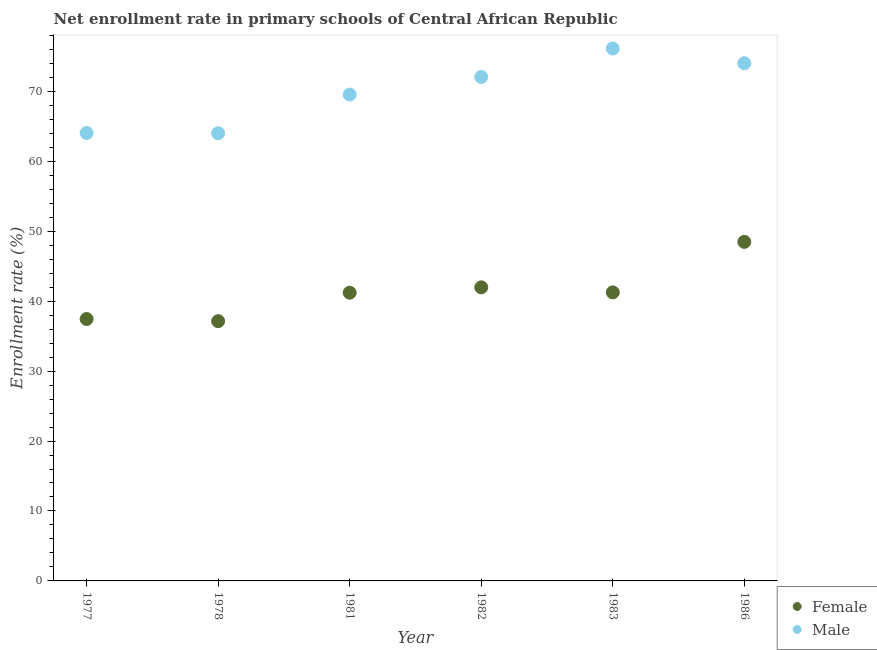What is the enrollment rate of male students in 1982?
Offer a very short reply. 72.04. Across all years, what is the maximum enrollment rate of male students?
Provide a short and direct response. 76.11. Across all years, what is the minimum enrollment rate of male students?
Keep it short and to the point. 64. In which year was the enrollment rate of female students maximum?
Provide a short and direct response. 1986. In which year was the enrollment rate of male students minimum?
Give a very brief answer. 1978. What is the total enrollment rate of female students in the graph?
Your answer should be compact. 247.47. What is the difference between the enrollment rate of male students in 1978 and that in 1981?
Provide a short and direct response. -5.53. What is the difference between the enrollment rate of female students in 1982 and the enrollment rate of male students in 1986?
Provide a short and direct response. -32.05. What is the average enrollment rate of male students per year?
Your response must be concise. 69.95. In the year 1978, what is the difference between the enrollment rate of female students and enrollment rate of male students?
Offer a terse response. -26.86. What is the ratio of the enrollment rate of female students in 1977 to that in 1986?
Make the answer very short. 0.77. Is the difference between the enrollment rate of male students in 1983 and 1986 greater than the difference between the enrollment rate of female students in 1983 and 1986?
Offer a very short reply. Yes. What is the difference between the highest and the second highest enrollment rate of female students?
Offer a terse response. 6.5. What is the difference between the highest and the lowest enrollment rate of male students?
Give a very brief answer. 12.12. In how many years, is the enrollment rate of female students greater than the average enrollment rate of female students taken over all years?
Offer a terse response. 3. Does the enrollment rate of male students monotonically increase over the years?
Ensure brevity in your answer.  No. Is the enrollment rate of male students strictly greater than the enrollment rate of female students over the years?
Keep it short and to the point. Yes. How many years are there in the graph?
Offer a terse response. 6. Where does the legend appear in the graph?
Your answer should be very brief. Bottom right. How are the legend labels stacked?
Your answer should be very brief. Vertical. What is the title of the graph?
Your answer should be compact. Net enrollment rate in primary schools of Central African Republic. What is the label or title of the Y-axis?
Give a very brief answer. Enrollment rate (%). What is the Enrollment rate (%) of Female in 1977?
Keep it short and to the point. 37.44. What is the Enrollment rate (%) of Male in 1977?
Ensure brevity in your answer.  64.03. What is the Enrollment rate (%) of Female in 1978?
Offer a very short reply. 37.13. What is the Enrollment rate (%) in Male in 1978?
Ensure brevity in your answer.  64. What is the Enrollment rate (%) of Female in 1981?
Give a very brief answer. 41.2. What is the Enrollment rate (%) of Male in 1981?
Make the answer very short. 69.53. What is the Enrollment rate (%) in Female in 1982?
Provide a succinct answer. 41.97. What is the Enrollment rate (%) of Male in 1982?
Offer a terse response. 72.04. What is the Enrollment rate (%) in Female in 1983?
Give a very brief answer. 41.25. What is the Enrollment rate (%) in Male in 1983?
Keep it short and to the point. 76.11. What is the Enrollment rate (%) of Female in 1986?
Provide a succinct answer. 48.47. What is the Enrollment rate (%) of Male in 1986?
Your answer should be very brief. 74.01. Across all years, what is the maximum Enrollment rate (%) of Female?
Your answer should be compact. 48.47. Across all years, what is the maximum Enrollment rate (%) in Male?
Offer a terse response. 76.11. Across all years, what is the minimum Enrollment rate (%) of Female?
Your response must be concise. 37.13. Across all years, what is the minimum Enrollment rate (%) of Male?
Offer a very short reply. 64. What is the total Enrollment rate (%) in Female in the graph?
Give a very brief answer. 247.47. What is the total Enrollment rate (%) of Male in the graph?
Your answer should be compact. 419.73. What is the difference between the Enrollment rate (%) in Female in 1977 and that in 1978?
Provide a short and direct response. 0.31. What is the difference between the Enrollment rate (%) in Male in 1977 and that in 1978?
Offer a very short reply. 0.04. What is the difference between the Enrollment rate (%) in Female in 1977 and that in 1981?
Ensure brevity in your answer.  -3.76. What is the difference between the Enrollment rate (%) in Male in 1977 and that in 1981?
Keep it short and to the point. -5.49. What is the difference between the Enrollment rate (%) of Female in 1977 and that in 1982?
Your response must be concise. -4.52. What is the difference between the Enrollment rate (%) in Male in 1977 and that in 1982?
Your answer should be very brief. -8.01. What is the difference between the Enrollment rate (%) of Female in 1977 and that in 1983?
Provide a succinct answer. -3.81. What is the difference between the Enrollment rate (%) of Male in 1977 and that in 1983?
Provide a succinct answer. -12.08. What is the difference between the Enrollment rate (%) in Female in 1977 and that in 1986?
Ensure brevity in your answer.  -11.03. What is the difference between the Enrollment rate (%) of Male in 1977 and that in 1986?
Your answer should be very brief. -9.98. What is the difference between the Enrollment rate (%) in Female in 1978 and that in 1981?
Provide a succinct answer. -4.07. What is the difference between the Enrollment rate (%) of Male in 1978 and that in 1981?
Give a very brief answer. -5.53. What is the difference between the Enrollment rate (%) of Female in 1978 and that in 1982?
Your response must be concise. -4.83. What is the difference between the Enrollment rate (%) in Male in 1978 and that in 1982?
Keep it short and to the point. -8.05. What is the difference between the Enrollment rate (%) in Female in 1978 and that in 1983?
Make the answer very short. -4.12. What is the difference between the Enrollment rate (%) of Male in 1978 and that in 1983?
Make the answer very short. -12.12. What is the difference between the Enrollment rate (%) of Female in 1978 and that in 1986?
Your answer should be very brief. -11.34. What is the difference between the Enrollment rate (%) of Male in 1978 and that in 1986?
Keep it short and to the point. -10.02. What is the difference between the Enrollment rate (%) of Female in 1981 and that in 1982?
Offer a terse response. -0.77. What is the difference between the Enrollment rate (%) of Male in 1981 and that in 1982?
Provide a succinct answer. -2.51. What is the difference between the Enrollment rate (%) in Female in 1981 and that in 1983?
Ensure brevity in your answer.  -0.05. What is the difference between the Enrollment rate (%) of Male in 1981 and that in 1983?
Your answer should be very brief. -6.58. What is the difference between the Enrollment rate (%) of Female in 1981 and that in 1986?
Offer a very short reply. -7.27. What is the difference between the Enrollment rate (%) of Male in 1981 and that in 1986?
Your answer should be compact. -4.49. What is the difference between the Enrollment rate (%) in Female in 1982 and that in 1983?
Your response must be concise. 0.72. What is the difference between the Enrollment rate (%) in Male in 1982 and that in 1983?
Your response must be concise. -4.07. What is the difference between the Enrollment rate (%) of Female in 1982 and that in 1986?
Provide a succinct answer. -6.5. What is the difference between the Enrollment rate (%) of Male in 1982 and that in 1986?
Give a very brief answer. -1.97. What is the difference between the Enrollment rate (%) of Female in 1983 and that in 1986?
Ensure brevity in your answer.  -7.22. What is the difference between the Enrollment rate (%) in Male in 1983 and that in 1986?
Provide a succinct answer. 2.1. What is the difference between the Enrollment rate (%) of Female in 1977 and the Enrollment rate (%) of Male in 1978?
Ensure brevity in your answer.  -26.55. What is the difference between the Enrollment rate (%) of Female in 1977 and the Enrollment rate (%) of Male in 1981?
Offer a terse response. -32.09. What is the difference between the Enrollment rate (%) of Female in 1977 and the Enrollment rate (%) of Male in 1982?
Keep it short and to the point. -34.6. What is the difference between the Enrollment rate (%) of Female in 1977 and the Enrollment rate (%) of Male in 1983?
Offer a terse response. -38.67. What is the difference between the Enrollment rate (%) of Female in 1977 and the Enrollment rate (%) of Male in 1986?
Give a very brief answer. -36.57. What is the difference between the Enrollment rate (%) in Female in 1978 and the Enrollment rate (%) in Male in 1981?
Your response must be concise. -32.4. What is the difference between the Enrollment rate (%) in Female in 1978 and the Enrollment rate (%) in Male in 1982?
Offer a terse response. -34.91. What is the difference between the Enrollment rate (%) of Female in 1978 and the Enrollment rate (%) of Male in 1983?
Your answer should be very brief. -38.98. What is the difference between the Enrollment rate (%) in Female in 1978 and the Enrollment rate (%) in Male in 1986?
Provide a short and direct response. -36.88. What is the difference between the Enrollment rate (%) in Female in 1981 and the Enrollment rate (%) in Male in 1982?
Make the answer very short. -30.84. What is the difference between the Enrollment rate (%) in Female in 1981 and the Enrollment rate (%) in Male in 1983?
Offer a very short reply. -34.91. What is the difference between the Enrollment rate (%) of Female in 1981 and the Enrollment rate (%) of Male in 1986?
Ensure brevity in your answer.  -32.81. What is the difference between the Enrollment rate (%) of Female in 1982 and the Enrollment rate (%) of Male in 1983?
Ensure brevity in your answer.  -34.15. What is the difference between the Enrollment rate (%) in Female in 1982 and the Enrollment rate (%) in Male in 1986?
Offer a terse response. -32.05. What is the difference between the Enrollment rate (%) in Female in 1983 and the Enrollment rate (%) in Male in 1986?
Offer a terse response. -32.77. What is the average Enrollment rate (%) in Female per year?
Ensure brevity in your answer.  41.24. What is the average Enrollment rate (%) of Male per year?
Ensure brevity in your answer.  69.95. In the year 1977, what is the difference between the Enrollment rate (%) of Female and Enrollment rate (%) of Male?
Offer a terse response. -26.59. In the year 1978, what is the difference between the Enrollment rate (%) of Female and Enrollment rate (%) of Male?
Your response must be concise. -26.86. In the year 1981, what is the difference between the Enrollment rate (%) in Female and Enrollment rate (%) in Male?
Your response must be concise. -28.33. In the year 1982, what is the difference between the Enrollment rate (%) in Female and Enrollment rate (%) in Male?
Provide a short and direct response. -30.07. In the year 1983, what is the difference between the Enrollment rate (%) in Female and Enrollment rate (%) in Male?
Keep it short and to the point. -34.87. In the year 1986, what is the difference between the Enrollment rate (%) in Female and Enrollment rate (%) in Male?
Provide a succinct answer. -25.54. What is the ratio of the Enrollment rate (%) in Female in 1977 to that in 1978?
Offer a very short reply. 1.01. What is the ratio of the Enrollment rate (%) in Male in 1977 to that in 1978?
Give a very brief answer. 1. What is the ratio of the Enrollment rate (%) of Female in 1977 to that in 1981?
Ensure brevity in your answer.  0.91. What is the ratio of the Enrollment rate (%) in Male in 1977 to that in 1981?
Your answer should be very brief. 0.92. What is the ratio of the Enrollment rate (%) in Female in 1977 to that in 1982?
Ensure brevity in your answer.  0.89. What is the ratio of the Enrollment rate (%) of Female in 1977 to that in 1983?
Provide a succinct answer. 0.91. What is the ratio of the Enrollment rate (%) in Male in 1977 to that in 1983?
Provide a short and direct response. 0.84. What is the ratio of the Enrollment rate (%) in Female in 1977 to that in 1986?
Provide a short and direct response. 0.77. What is the ratio of the Enrollment rate (%) of Male in 1977 to that in 1986?
Provide a succinct answer. 0.87. What is the ratio of the Enrollment rate (%) in Female in 1978 to that in 1981?
Your response must be concise. 0.9. What is the ratio of the Enrollment rate (%) of Male in 1978 to that in 1981?
Provide a short and direct response. 0.92. What is the ratio of the Enrollment rate (%) of Female in 1978 to that in 1982?
Provide a succinct answer. 0.88. What is the ratio of the Enrollment rate (%) of Male in 1978 to that in 1982?
Your answer should be very brief. 0.89. What is the ratio of the Enrollment rate (%) of Female in 1978 to that in 1983?
Your answer should be very brief. 0.9. What is the ratio of the Enrollment rate (%) in Male in 1978 to that in 1983?
Give a very brief answer. 0.84. What is the ratio of the Enrollment rate (%) of Female in 1978 to that in 1986?
Provide a short and direct response. 0.77. What is the ratio of the Enrollment rate (%) in Male in 1978 to that in 1986?
Your answer should be very brief. 0.86. What is the ratio of the Enrollment rate (%) of Female in 1981 to that in 1982?
Your answer should be compact. 0.98. What is the ratio of the Enrollment rate (%) in Male in 1981 to that in 1982?
Keep it short and to the point. 0.97. What is the ratio of the Enrollment rate (%) in Female in 1981 to that in 1983?
Your answer should be very brief. 1. What is the ratio of the Enrollment rate (%) of Male in 1981 to that in 1983?
Offer a very short reply. 0.91. What is the ratio of the Enrollment rate (%) in Female in 1981 to that in 1986?
Offer a terse response. 0.85. What is the ratio of the Enrollment rate (%) of Male in 1981 to that in 1986?
Give a very brief answer. 0.94. What is the ratio of the Enrollment rate (%) of Female in 1982 to that in 1983?
Your response must be concise. 1.02. What is the ratio of the Enrollment rate (%) of Male in 1982 to that in 1983?
Your answer should be compact. 0.95. What is the ratio of the Enrollment rate (%) in Female in 1982 to that in 1986?
Provide a short and direct response. 0.87. What is the ratio of the Enrollment rate (%) in Male in 1982 to that in 1986?
Your answer should be very brief. 0.97. What is the ratio of the Enrollment rate (%) of Female in 1983 to that in 1986?
Ensure brevity in your answer.  0.85. What is the ratio of the Enrollment rate (%) in Male in 1983 to that in 1986?
Provide a succinct answer. 1.03. What is the difference between the highest and the second highest Enrollment rate (%) of Female?
Your answer should be compact. 6.5. What is the difference between the highest and the second highest Enrollment rate (%) of Male?
Offer a very short reply. 2.1. What is the difference between the highest and the lowest Enrollment rate (%) in Female?
Offer a very short reply. 11.34. What is the difference between the highest and the lowest Enrollment rate (%) in Male?
Your response must be concise. 12.12. 